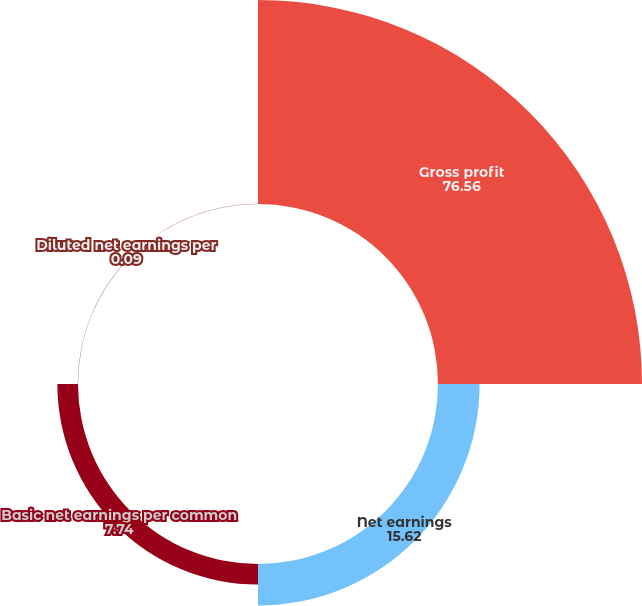Convert chart. <chart><loc_0><loc_0><loc_500><loc_500><pie_chart><fcel>Gross profit<fcel>Net earnings<fcel>Basic net earnings per common<fcel>Diluted net earnings per<nl><fcel>76.56%<fcel>15.62%<fcel>7.74%<fcel>0.09%<nl></chart> 